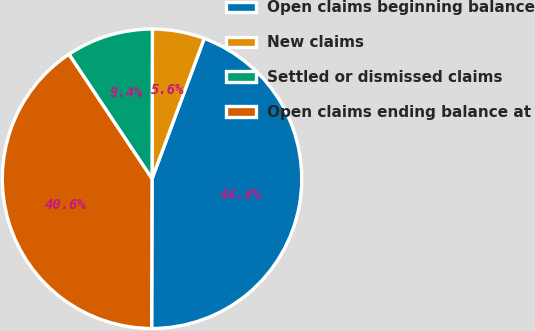Convert chart to OTSL. <chart><loc_0><loc_0><loc_500><loc_500><pie_chart><fcel>Open claims beginning balance<fcel>New claims<fcel>Settled or dismissed claims<fcel>Open claims ending balance at<nl><fcel>44.37%<fcel>5.63%<fcel>9.41%<fcel>40.59%<nl></chart> 